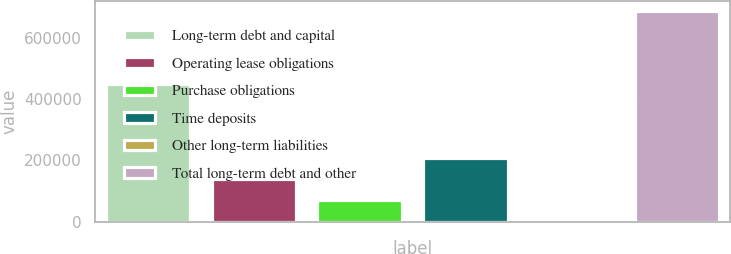<chart> <loc_0><loc_0><loc_500><loc_500><bar_chart><fcel>Long-term debt and capital<fcel>Operating lease obligations<fcel>Purchase obligations<fcel>Time deposits<fcel>Other long-term liabilities<fcel>Total long-term debt and other<nl><fcel>448431<fcel>140436<fcel>72049.6<fcel>208823<fcel>3663<fcel>687529<nl></chart> 